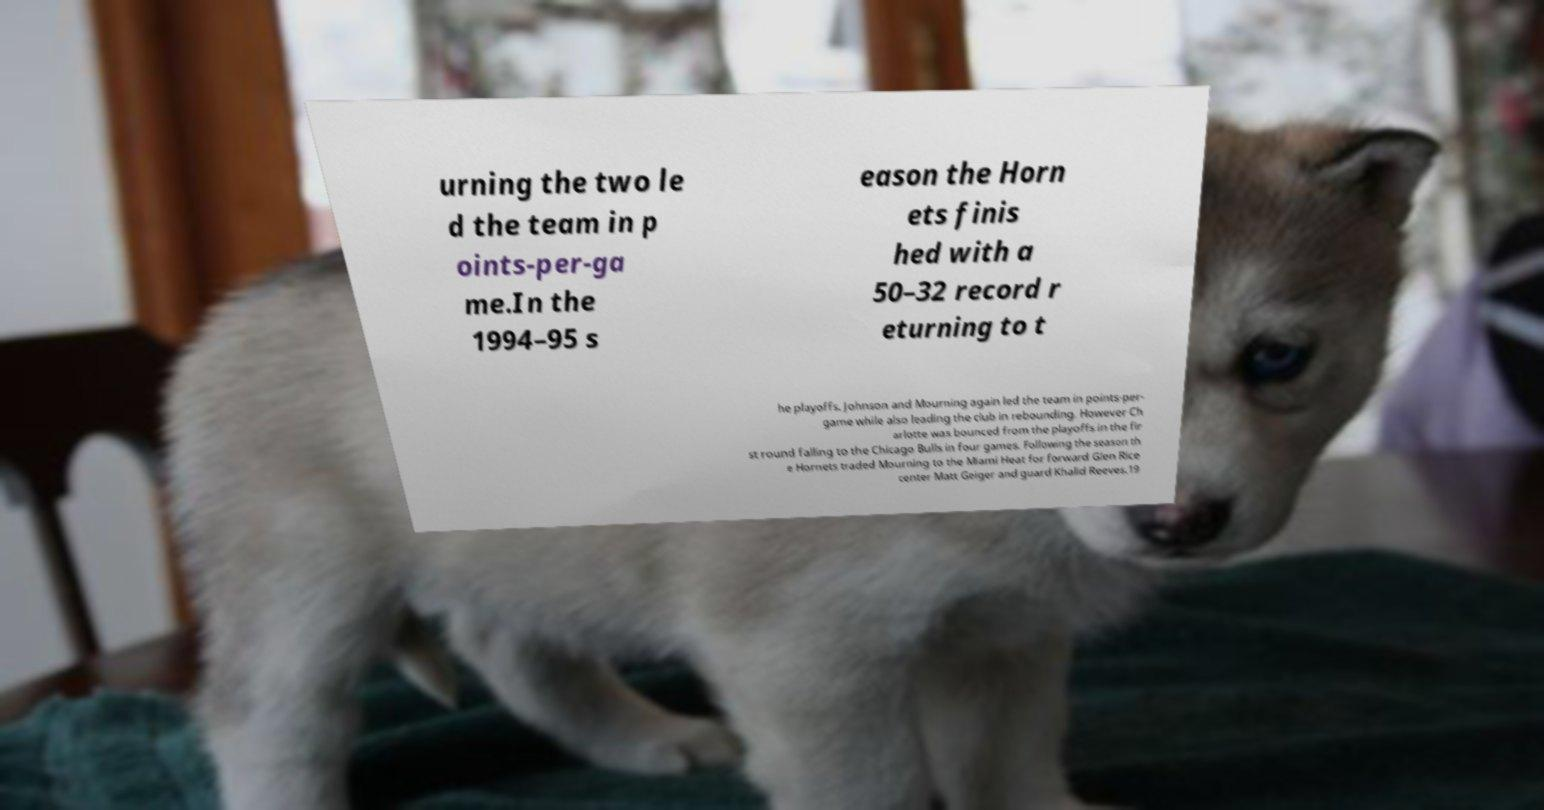Please identify and transcribe the text found in this image. urning the two le d the team in p oints-per-ga me.In the 1994–95 s eason the Horn ets finis hed with a 50–32 record r eturning to t he playoffs. Johnson and Mourning again led the team in points-per- game while also leading the club in rebounding. However Ch arlotte was bounced from the playoffs in the fir st round falling to the Chicago Bulls in four games. Following the season th e Hornets traded Mourning to the Miami Heat for forward Glen Rice center Matt Geiger and guard Khalid Reeves.19 